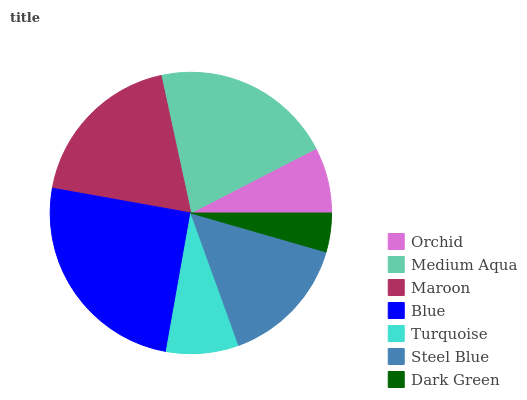Is Dark Green the minimum?
Answer yes or no. Yes. Is Blue the maximum?
Answer yes or no. Yes. Is Medium Aqua the minimum?
Answer yes or no. No. Is Medium Aqua the maximum?
Answer yes or no. No. Is Medium Aqua greater than Orchid?
Answer yes or no. Yes. Is Orchid less than Medium Aqua?
Answer yes or no. Yes. Is Orchid greater than Medium Aqua?
Answer yes or no. No. Is Medium Aqua less than Orchid?
Answer yes or no. No. Is Steel Blue the high median?
Answer yes or no. Yes. Is Steel Blue the low median?
Answer yes or no. Yes. Is Dark Green the high median?
Answer yes or no. No. Is Blue the low median?
Answer yes or no. No. 